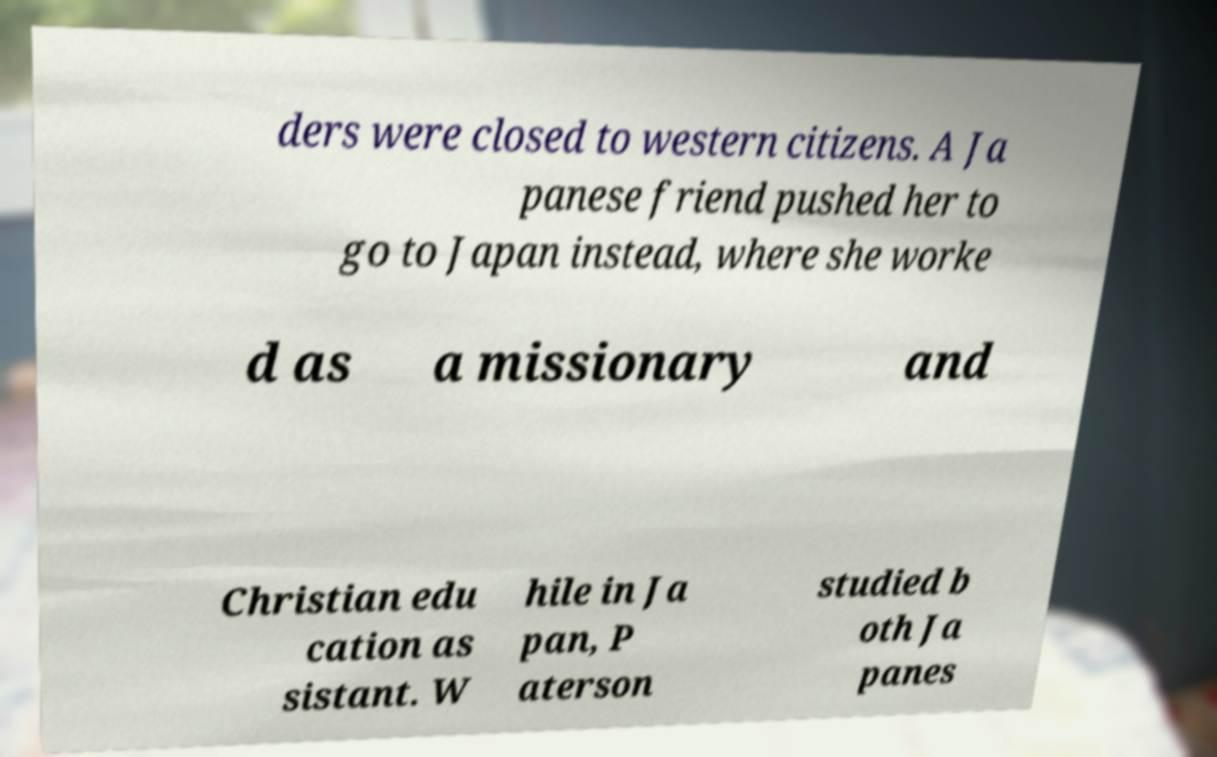Please identify and transcribe the text found in this image. ders were closed to western citizens. A Ja panese friend pushed her to go to Japan instead, where she worke d as a missionary and Christian edu cation as sistant. W hile in Ja pan, P aterson studied b oth Ja panes 